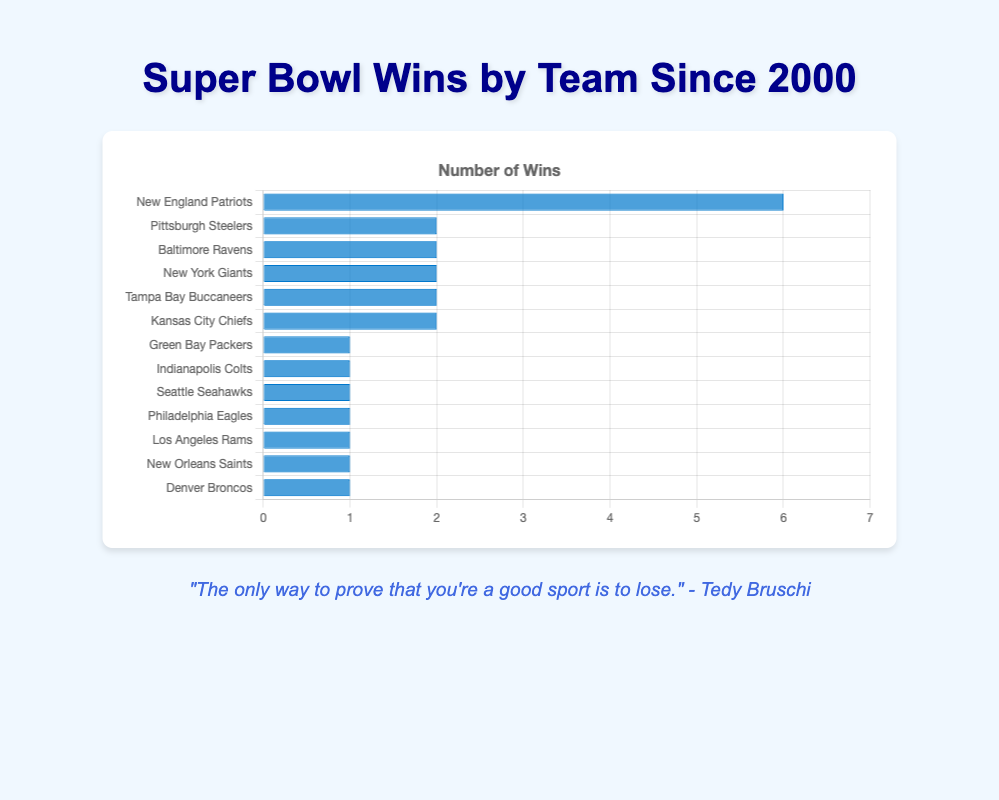Which team has the most Super Bowl wins since 2000? The chart shows the data of Super Bowl wins post-2000 for different teams, and the team with the highest bar represents the most wins. The New England Patriots have the highest bar with 6 wins.
Answer: New England Patriots How many teams have exactly 2 Super Bowl wins since 2000? The chart displays the number of wins for each team. Teams with exactly 2 wins have bars extending to the number 2. There are five such teams: Pittsburgh Steelers, Baltimore Ravens, New York Giants, Tampa Bay Buccaneers, and Kansas City Chiefs.
Answer: 5 Which teams have only 1 Super Bowl win since 2000? Teams with only 1 win have bars extending to the number 1. The chart shows that these teams are Green Bay Packers, Indianapolis Colts, Seattle Seahawks, Philadelphia Eagles, Los Angeles Rams, New Orleans Saints, and Denver Broncos.
Answer: Green Bay Packers, Indianapolis Colts, Seattle Seahawks, Philadelphia Eagles, Los Angeles Rams, New Orleans Saints, Denver Broncos What's the difference in the number of wins between the New England Patriots and the Pittsburgh Steelers? The Patriots have 6 wins and the Steelers have 2 wins. The difference is calculated as 6 - 2.
Answer: 4 What is the total number of Super Bowl wins by all teams since 2000? Sum the wins of all teams shown in the chart: 6 + 2 + 2 + 2 + 2 + 2 + 1 + 1 + 1 + 1 + 1 + 1 + 1 = 23.
Answer: 23 Compare the Super Bowl wins of the Kansas City Chiefs and the Baltimore Ravens. Which team has more wins? Both the Kansas City Chiefs and the Baltimore Ravens have bars indicating 2 wins each. Hence, neither team has more wins than the other; they are equal.
Answer: Equal What is the average number of Super Bowl wins per team since 2000? There are 13 teams and the total number of wins is 23. The average is calculated by dividing the total wins by the number of teams: 23 / 13 ≈ 1.77.
Answer: 1.77 Which team has fewer wins, the New Orleans Saints or the Green Bay Packers? Both the New Orleans Saints and the Green Bay Packers have bars extending to the number 1, indicating they each have 1 win. Therefore, neither team has fewer wins than the other; they are equal.
Answer: Equal 